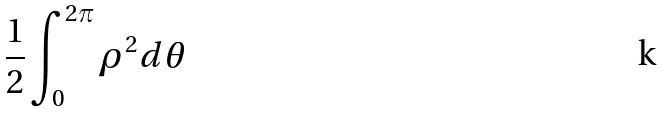Convert formula to latex. <formula><loc_0><loc_0><loc_500><loc_500>\frac { 1 } { 2 } \int _ { 0 } ^ { 2 \pi } \rho ^ { 2 } d \theta</formula> 